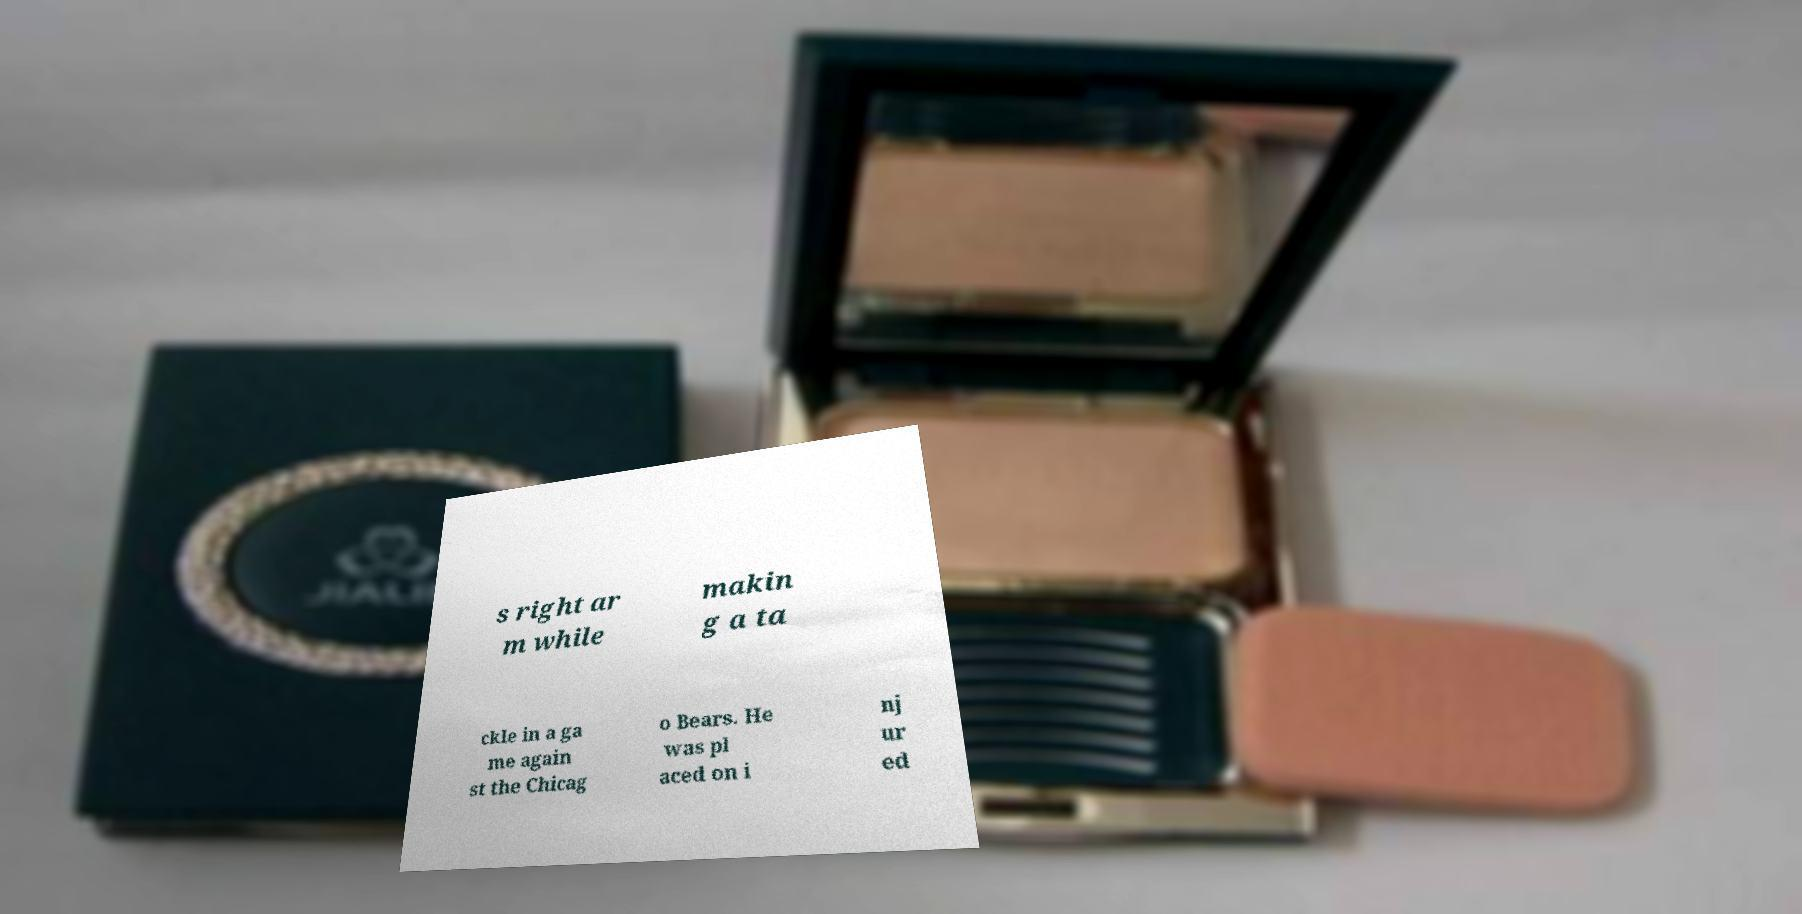I need the written content from this picture converted into text. Can you do that? s right ar m while makin g a ta ckle in a ga me again st the Chicag o Bears. He was pl aced on i nj ur ed 